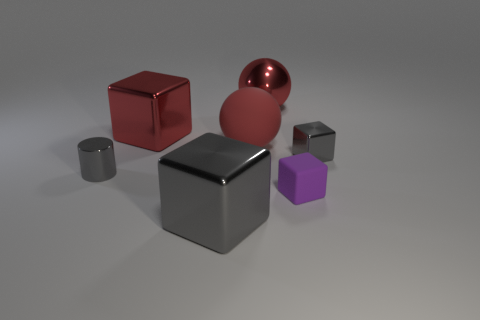Add 1 big blue metallic spheres. How many objects exist? 8 Subtract all cylinders. How many objects are left? 6 Add 1 purple rubber things. How many purple rubber things exist? 2 Subtract 0 red cylinders. How many objects are left? 7 Subtract all tiny blue metallic cylinders. Subtract all tiny gray metallic cylinders. How many objects are left? 6 Add 7 small gray cubes. How many small gray cubes are left? 8 